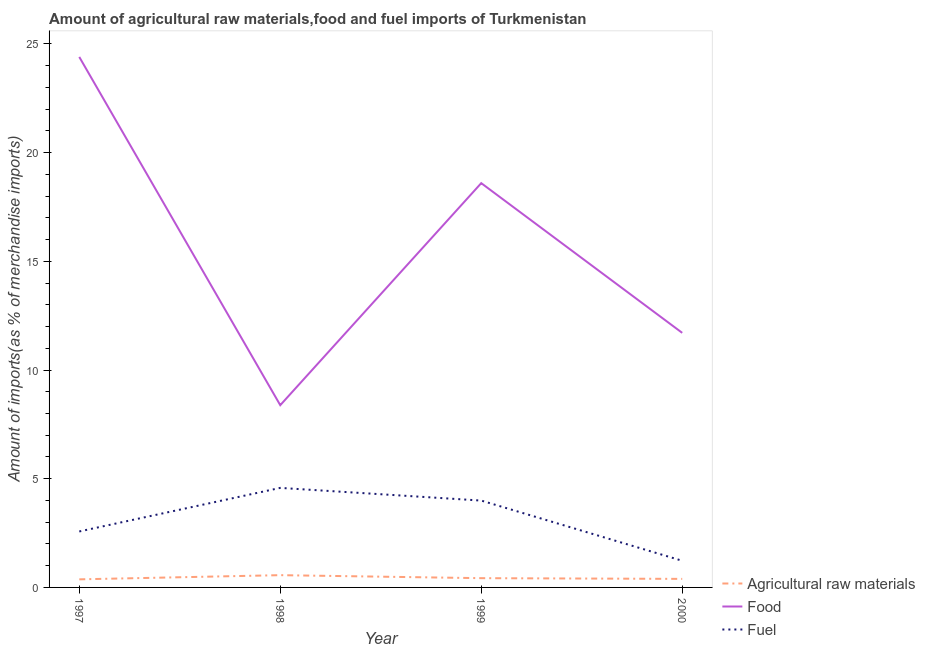How many different coloured lines are there?
Provide a succinct answer. 3. Does the line corresponding to percentage of food imports intersect with the line corresponding to percentage of fuel imports?
Keep it short and to the point. No. What is the percentage of fuel imports in 1999?
Offer a very short reply. 4. Across all years, what is the maximum percentage of fuel imports?
Offer a terse response. 4.58. Across all years, what is the minimum percentage of raw materials imports?
Offer a terse response. 0.37. What is the total percentage of food imports in the graph?
Your response must be concise. 63.1. What is the difference between the percentage of fuel imports in 1997 and that in 1999?
Ensure brevity in your answer.  -1.42. What is the difference between the percentage of fuel imports in 1997 and the percentage of food imports in 1999?
Ensure brevity in your answer.  -16.02. What is the average percentage of food imports per year?
Provide a succinct answer. 15.77. In the year 1997, what is the difference between the percentage of food imports and percentage of raw materials imports?
Your answer should be compact. 24.03. In how many years, is the percentage of food imports greater than 15 %?
Your answer should be compact. 2. What is the ratio of the percentage of food imports in 1997 to that in 2000?
Your response must be concise. 2.08. What is the difference between the highest and the second highest percentage of fuel imports?
Offer a very short reply. 0.58. What is the difference between the highest and the lowest percentage of fuel imports?
Give a very brief answer. 3.35. In how many years, is the percentage of raw materials imports greater than the average percentage of raw materials imports taken over all years?
Provide a succinct answer. 1. Is the sum of the percentage of raw materials imports in 1998 and 1999 greater than the maximum percentage of fuel imports across all years?
Give a very brief answer. No. Does the percentage of fuel imports monotonically increase over the years?
Offer a very short reply. No. How many lines are there?
Offer a terse response. 3. How many years are there in the graph?
Offer a terse response. 4. Are the values on the major ticks of Y-axis written in scientific E-notation?
Provide a short and direct response. No. Does the graph contain grids?
Make the answer very short. No. How many legend labels are there?
Provide a succinct answer. 3. How are the legend labels stacked?
Offer a terse response. Vertical. What is the title of the graph?
Give a very brief answer. Amount of agricultural raw materials,food and fuel imports of Turkmenistan. What is the label or title of the Y-axis?
Make the answer very short. Amount of imports(as % of merchandise imports). What is the Amount of imports(as % of merchandise imports) in Agricultural raw materials in 1997?
Your response must be concise. 0.37. What is the Amount of imports(as % of merchandise imports) of Food in 1997?
Offer a very short reply. 24.4. What is the Amount of imports(as % of merchandise imports) in Fuel in 1997?
Offer a terse response. 2.57. What is the Amount of imports(as % of merchandise imports) of Agricultural raw materials in 1998?
Offer a terse response. 0.56. What is the Amount of imports(as % of merchandise imports) of Food in 1998?
Offer a terse response. 8.38. What is the Amount of imports(as % of merchandise imports) of Fuel in 1998?
Your answer should be compact. 4.58. What is the Amount of imports(as % of merchandise imports) of Agricultural raw materials in 1999?
Your response must be concise. 0.43. What is the Amount of imports(as % of merchandise imports) in Food in 1999?
Offer a very short reply. 18.6. What is the Amount of imports(as % of merchandise imports) in Fuel in 1999?
Keep it short and to the point. 4. What is the Amount of imports(as % of merchandise imports) in Agricultural raw materials in 2000?
Ensure brevity in your answer.  0.39. What is the Amount of imports(as % of merchandise imports) of Food in 2000?
Provide a succinct answer. 11.71. What is the Amount of imports(as % of merchandise imports) in Fuel in 2000?
Your answer should be compact. 1.23. Across all years, what is the maximum Amount of imports(as % of merchandise imports) of Agricultural raw materials?
Provide a short and direct response. 0.56. Across all years, what is the maximum Amount of imports(as % of merchandise imports) of Food?
Provide a short and direct response. 24.4. Across all years, what is the maximum Amount of imports(as % of merchandise imports) of Fuel?
Give a very brief answer. 4.58. Across all years, what is the minimum Amount of imports(as % of merchandise imports) in Agricultural raw materials?
Provide a succinct answer. 0.37. Across all years, what is the minimum Amount of imports(as % of merchandise imports) in Food?
Ensure brevity in your answer.  8.38. Across all years, what is the minimum Amount of imports(as % of merchandise imports) of Fuel?
Your answer should be very brief. 1.23. What is the total Amount of imports(as % of merchandise imports) of Agricultural raw materials in the graph?
Make the answer very short. 1.75. What is the total Amount of imports(as % of merchandise imports) of Food in the graph?
Make the answer very short. 63.1. What is the total Amount of imports(as % of merchandise imports) of Fuel in the graph?
Your answer should be compact. 12.38. What is the difference between the Amount of imports(as % of merchandise imports) of Agricultural raw materials in 1997 and that in 1998?
Make the answer very short. -0.19. What is the difference between the Amount of imports(as % of merchandise imports) of Food in 1997 and that in 1998?
Your answer should be very brief. 16.02. What is the difference between the Amount of imports(as % of merchandise imports) of Fuel in 1997 and that in 1998?
Give a very brief answer. -2. What is the difference between the Amount of imports(as % of merchandise imports) of Agricultural raw materials in 1997 and that in 1999?
Ensure brevity in your answer.  -0.05. What is the difference between the Amount of imports(as % of merchandise imports) in Food in 1997 and that in 1999?
Give a very brief answer. 5.81. What is the difference between the Amount of imports(as % of merchandise imports) of Fuel in 1997 and that in 1999?
Ensure brevity in your answer.  -1.42. What is the difference between the Amount of imports(as % of merchandise imports) of Agricultural raw materials in 1997 and that in 2000?
Give a very brief answer. -0.02. What is the difference between the Amount of imports(as % of merchandise imports) of Food in 1997 and that in 2000?
Your answer should be very brief. 12.69. What is the difference between the Amount of imports(as % of merchandise imports) in Fuel in 1997 and that in 2000?
Offer a terse response. 1.35. What is the difference between the Amount of imports(as % of merchandise imports) of Agricultural raw materials in 1998 and that in 1999?
Make the answer very short. 0.14. What is the difference between the Amount of imports(as % of merchandise imports) of Food in 1998 and that in 1999?
Your response must be concise. -10.21. What is the difference between the Amount of imports(as % of merchandise imports) of Fuel in 1998 and that in 1999?
Your answer should be very brief. 0.58. What is the difference between the Amount of imports(as % of merchandise imports) in Agricultural raw materials in 1998 and that in 2000?
Your answer should be very brief. 0.17. What is the difference between the Amount of imports(as % of merchandise imports) of Food in 1998 and that in 2000?
Your answer should be compact. -3.33. What is the difference between the Amount of imports(as % of merchandise imports) in Fuel in 1998 and that in 2000?
Your answer should be very brief. 3.35. What is the difference between the Amount of imports(as % of merchandise imports) in Agricultural raw materials in 1999 and that in 2000?
Your answer should be very brief. 0.03. What is the difference between the Amount of imports(as % of merchandise imports) in Food in 1999 and that in 2000?
Offer a terse response. 6.89. What is the difference between the Amount of imports(as % of merchandise imports) in Fuel in 1999 and that in 2000?
Offer a very short reply. 2.77. What is the difference between the Amount of imports(as % of merchandise imports) of Agricultural raw materials in 1997 and the Amount of imports(as % of merchandise imports) of Food in 1998?
Offer a very short reply. -8.01. What is the difference between the Amount of imports(as % of merchandise imports) in Agricultural raw materials in 1997 and the Amount of imports(as % of merchandise imports) in Fuel in 1998?
Offer a terse response. -4.21. What is the difference between the Amount of imports(as % of merchandise imports) of Food in 1997 and the Amount of imports(as % of merchandise imports) of Fuel in 1998?
Your answer should be very brief. 19.82. What is the difference between the Amount of imports(as % of merchandise imports) in Agricultural raw materials in 1997 and the Amount of imports(as % of merchandise imports) in Food in 1999?
Provide a succinct answer. -18.23. What is the difference between the Amount of imports(as % of merchandise imports) of Agricultural raw materials in 1997 and the Amount of imports(as % of merchandise imports) of Fuel in 1999?
Your response must be concise. -3.62. What is the difference between the Amount of imports(as % of merchandise imports) of Food in 1997 and the Amount of imports(as % of merchandise imports) of Fuel in 1999?
Your answer should be compact. 20.41. What is the difference between the Amount of imports(as % of merchandise imports) in Agricultural raw materials in 1997 and the Amount of imports(as % of merchandise imports) in Food in 2000?
Give a very brief answer. -11.34. What is the difference between the Amount of imports(as % of merchandise imports) in Agricultural raw materials in 1997 and the Amount of imports(as % of merchandise imports) in Fuel in 2000?
Your answer should be compact. -0.85. What is the difference between the Amount of imports(as % of merchandise imports) in Food in 1997 and the Amount of imports(as % of merchandise imports) in Fuel in 2000?
Make the answer very short. 23.18. What is the difference between the Amount of imports(as % of merchandise imports) of Agricultural raw materials in 1998 and the Amount of imports(as % of merchandise imports) of Food in 1999?
Offer a very short reply. -18.03. What is the difference between the Amount of imports(as % of merchandise imports) in Agricultural raw materials in 1998 and the Amount of imports(as % of merchandise imports) in Fuel in 1999?
Provide a succinct answer. -3.43. What is the difference between the Amount of imports(as % of merchandise imports) in Food in 1998 and the Amount of imports(as % of merchandise imports) in Fuel in 1999?
Provide a succinct answer. 4.39. What is the difference between the Amount of imports(as % of merchandise imports) of Agricultural raw materials in 1998 and the Amount of imports(as % of merchandise imports) of Food in 2000?
Your response must be concise. -11.15. What is the difference between the Amount of imports(as % of merchandise imports) in Agricultural raw materials in 1998 and the Amount of imports(as % of merchandise imports) in Fuel in 2000?
Your answer should be very brief. -0.66. What is the difference between the Amount of imports(as % of merchandise imports) of Food in 1998 and the Amount of imports(as % of merchandise imports) of Fuel in 2000?
Give a very brief answer. 7.16. What is the difference between the Amount of imports(as % of merchandise imports) of Agricultural raw materials in 1999 and the Amount of imports(as % of merchandise imports) of Food in 2000?
Ensure brevity in your answer.  -11.28. What is the difference between the Amount of imports(as % of merchandise imports) in Agricultural raw materials in 1999 and the Amount of imports(as % of merchandise imports) in Fuel in 2000?
Keep it short and to the point. -0.8. What is the difference between the Amount of imports(as % of merchandise imports) in Food in 1999 and the Amount of imports(as % of merchandise imports) in Fuel in 2000?
Your response must be concise. 17.37. What is the average Amount of imports(as % of merchandise imports) of Agricultural raw materials per year?
Keep it short and to the point. 0.44. What is the average Amount of imports(as % of merchandise imports) of Food per year?
Make the answer very short. 15.77. What is the average Amount of imports(as % of merchandise imports) in Fuel per year?
Provide a short and direct response. 3.09. In the year 1997, what is the difference between the Amount of imports(as % of merchandise imports) of Agricultural raw materials and Amount of imports(as % of merchandise imports) of Food?
Your response must be concise. -24.03. In the year 1997, what is the difference between the Amount of imports(as % of merchandise imports) of Agricultural raw materials and Amount of imports(as % of merchandise imports) of Fuel?
Your answer should be compact. -2.2. In the year 1997, what is the difference between the Amount of imports(as % of merchandise imports) in Food and Amount of imports(as % of merchandise imports) in Fuel?
Give a very brief answer. 21.83. In the year 1998, what is the difference between the Amount of imports(as % of merchandise imports) in Agricultural raw materials and Amount of imports(as % of merchandise imports) in Food?
Keep it short and to the point. -7.82. In the year 1998, what is the difference between the Amount of imports(as % of merchandise imports) in Agricultural raw materials and Amount of imports(as % of merchandise imports) in Fuel?
Offer a terse response. -4.01. In the year 1998, what is the difference between the Amount of imports(as % of merchandise imports) of Food and Amount of imports(as % of merchandise imports) of Fuel?
Make the answer very short. 3.81. In the year 1999, what is the difference between the Amount of imports(as % of merchandise imports) of Agricultural raw materials and Amount of imports(as % of merchandise imports) of Food?
Give a very brief answer. -18.17. In the year 1999, what is the difference between the Amount of imports(as % of merchandise imports) in Agricultural raw materials and Amount of imports(as % of merchandise imports) in Fuel?
Your answer should be compact. -3.57. In the year 1999, what is the difference between the Amount of imports(as % of merchandise imports) of Food and Amount of imports(as % of merchandise imports) of Fuel?
Keep it short and to the point. 14.6. In the year 2000, what is the difference between the Amount of imports(as % of merchandise imports) in Agricultural raw materials and Amount of imports(as % of merchandise imports) in Food?
Make the answer very short. -11.32. In the year 2000, what is the difference between the Amount of imports(as % of merchandise imports) in Agricultural raw materials and Amount of imports(as % of merchandise imports) in Fuel?
Ensure brevity in your answer.  -0.83. In the year 2000, what is the difference between the Amount of imports(as % of merchandise imports) in Food and Amount of imports(as % of merchandise imports) in Fuel?
Your answer should be compact. 10.48. What is the ratio of the Amount of imports(as % of merchandise imports) in Agricultural raw materials in 1997 to that in 1998?
Provide a succinct answer. 0.66. What is the ratio of the Amount of imports(as % of merchandise imports) of Food in 1997 to that in 1998?
Provide a short and direct response. 2.91. What is the ratio of the Amount of imports(as % of merchandise imports) of Fuel in 1997 to that in 1998?
Offer a very short reply. 0.56. What is the ratio of the Amount of imports(as % of merchandise imports) in Agricultural raw materials in 1997 to that in 1999?
Provide a succinct answer. 0.87. What is the ratio of the Amount of imports(as % of merchandise imports) in Food in 1997 to that in 1999?
Offer a very short reply. 1.31. What is the ratio of the Amount of imports(as % of merchandise imports) of Fuel in 1997 to that in 1999?
Provide a succinct answer. 0.64. What is the ratio of the Amount of imports(as % of merchandise imports) of Agricultural raw materials in 1997 to that in 2000?
Your response must be concise. 0.95. What is the ratio of the Amount of imports(as % of merchandise imports) of Food in 1997 to that in 2000?
Offer a terse response. 2.08. What is the ratio of the Amount of imports(as % of merchandise imports) in Fuel in 1997 to that in 2000?
Offer a very short reply. 2.1. What is the ratio of the Amount of imports(as % of merchandise imports) in Agricultural raw materials in 1998 to that in 1999?
Keep it short and to the point. 1.33. What is the ratio of the Amount of imports(as % of merchandise imports) of Food in 1998 to that in 1999?
Give a very brief answer. 0.45. What is the ratio of the Amount of imports(as % of merchandise imports) of Fuel in 1998 to that in 1999?
Ensure brevity in your answer.  1.15. What is the ratio of the Amount of imports(as % of merchandise imports) of Agricultural raw materials in 1998 to that in 2000?
Offer a very short reply. 1.44. What is the ratio of the Amount of imports(as % of merchandise imports) in Food in 1998 to that in 2000?
Your response must be concise. 0.72. What is the ratio of the Amount of imports(as % of merchandise imports) of Fuel in 1998 to that in 2000?
Make the answer very short. 3.73. What is the ratio of the Amount of imports(as % of merchandise imports) in Agricultural raw materials in 1999 to that in 2000?
Your response must be concise. 1.08. What is the ratio of the Amount of imports(as % of merchandise imports) of Food in 1999 to that in 2000?
Your answer should be very brief. 1.59. What is the ratio of the Amount of imports(as % of merchandise imports) of Fuel in 1999 to that in 2000?
Give a very brief answer. 3.26. What is the difference between the highest and the second highest Amount of imports(as % of merchandise imports) in Agricultural raw materials?
Your answer should be compact. 0.14. What is the difference between the highest and the second highest Amount of imports(as % of merchandise imports) of Food?
Offer a terse response. 5.81. What is the difference between the highest and the second highest Amount of imports(as % of merchandise imports) of Fuel?
Give a very brief answer. 0.58. What is the difference between the highest and the lowest Amount of imports(as % of merchandise imports) in Agricultural raw materials?
Offer a very short reply. 0.19. What is the difference between the highest and the lowest Amount of imports(as % of merchandise imports) of Food?
Offer a terse response. 16.02. What is the difference between the highest and the lowest Amount of imports(as % of merchandise imports) of Fuel?
Your response must be concise. 3.35. 